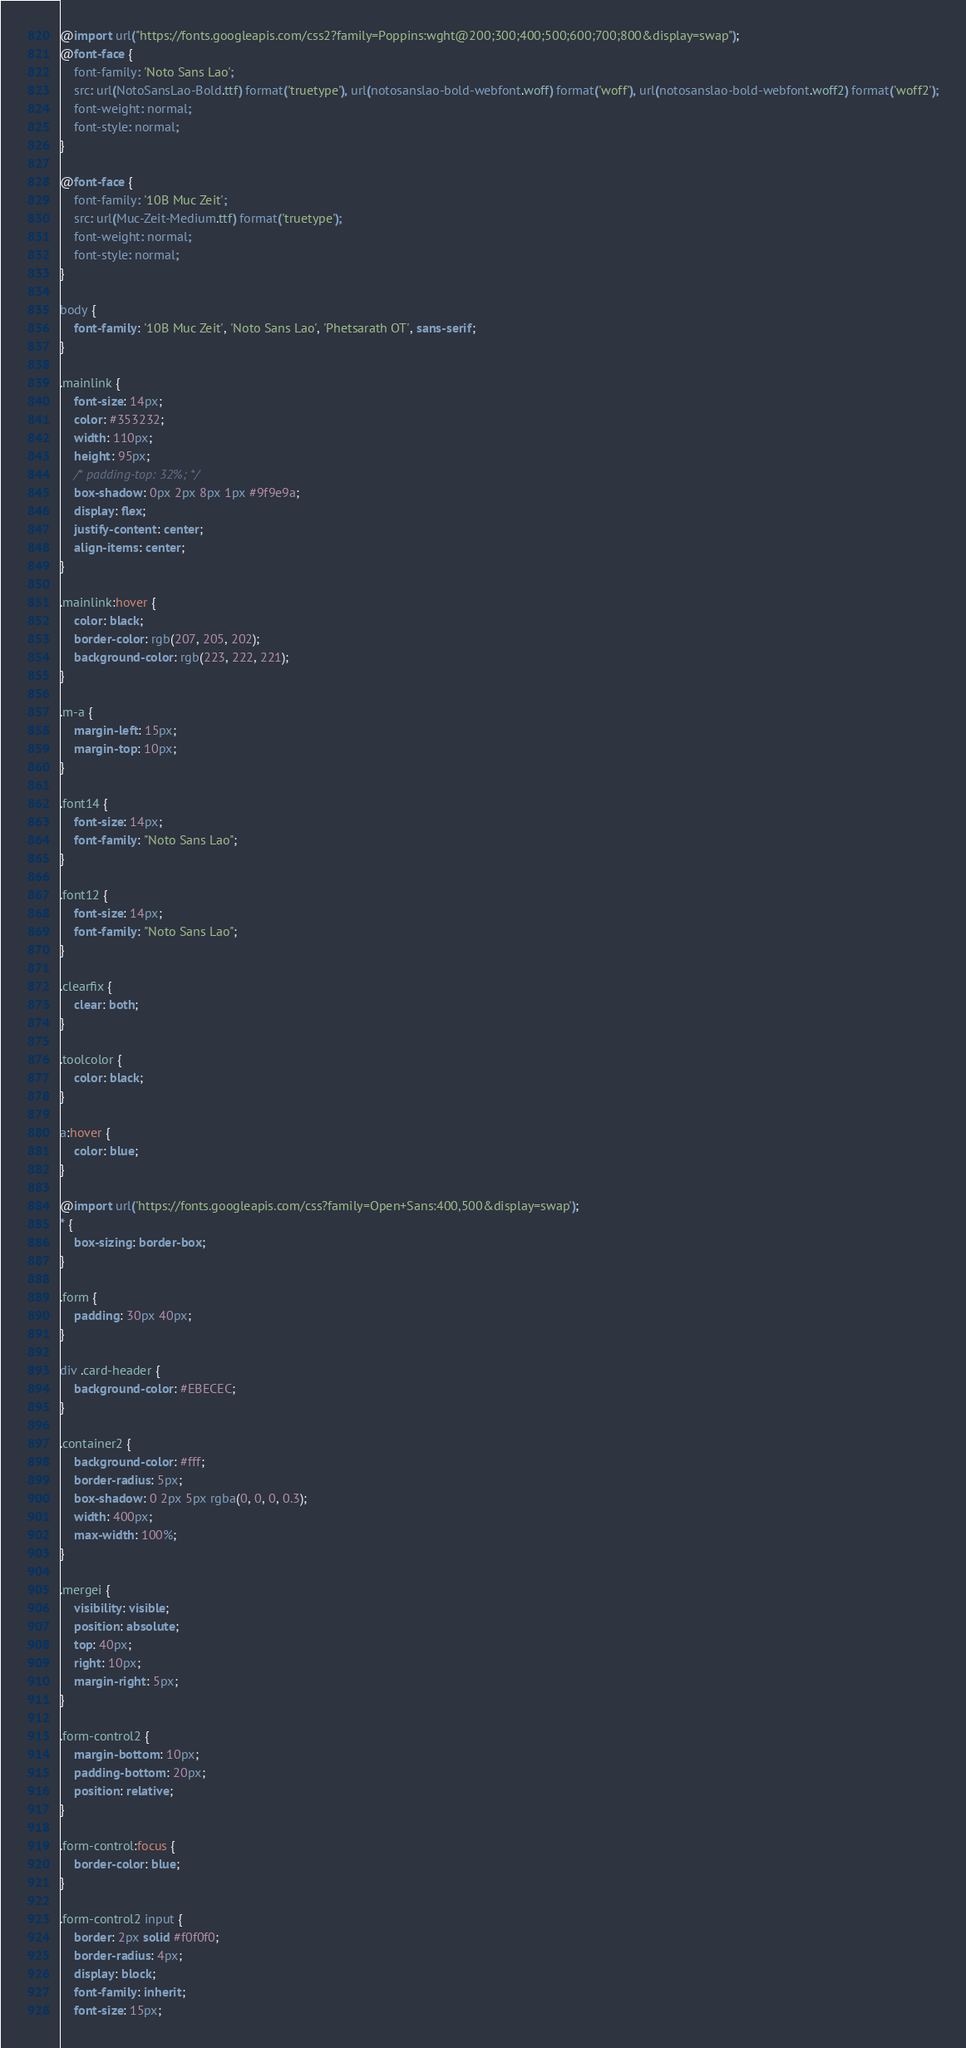<code> <loc_0><loc_0><loc_500><loc_500><_CSS_>@import url("https://fonts.googleapis.com/css2?family=Poppins:wght@200;300;400;500;600;700;800&display=swap");
@font-face {
    font-family: 'Noto Sans Lao';
    src: url(NotoSansLao-Bold.ttf) format('truetype'), url(notosanslao-bold-webfont.woff) format('woff'), url(notosanslao-bold-webfont.woff2) format('woff2');
    font-weight: normal;
    font-style: normal;
}

@font-face {
    font-family: '10B Muc Zeit';
    src: url(Muc-Zeit-Medium.ttf) format('truetype');
    font-weight: normal;
    font-style: normal;
}

body {
    font-family: '10B Muc Zeit', 'Noto Sans Lao', 'Phetsarath OT', sans-serif;
}

.mainlink {
    font-size: 14px;
    color: #353232;
    width: 110px;
    height: 95px;
    /* padding-top: 32%; */
    box-shadow: 0px 2px 8px 1px #9f9e9a;
    display: flex;
    justify-content: center;
    align-items: center;
}

.mainlink:hover {
    color: black;
    border-color: rgb(207, 205, 202);
    background-color: rgb(223, 222, 221);
}

.m-a {
    margin-left: 15px;
    margin-top: 10px;
}

.font14 {
    font-size: 14px;
    font-family: "Noto Sans Lao";
}

.font12 {
    font-size: 14px;
    font-family: "Noto Sans Lao";
}

.clearfix {
    clear: both;
}

.toolcolor {
    color: black;
}

a:hover {
    color: blue;
}

@import url('https://fonts.googleapis.com/css?family=Open+Sans:400,500&display=swap');
* {
    box-sizing: border-box;
}

.form {
    padding: 30px 40px;
}

div .card-header {
    background-color: #EBECEC;
}

.container2 {
    background-color: #fff;
    border-radius: 5px;
    box-shadow: 0 2px 5px rgba(0, 0, 0, 0.3);
    width: 400px;
    max-width: 100%;
}

.mergei {
    visibility: visible;
    position: absolute;
    top: 40px;
    right: 10px;
    margin-right: 5px;
}

.form-control2 {
    margin-bottom: 10px;
    padding-bottom: 20px;
    position: relative;
}

.form-control:focus {
    border-color: blue;
}

.form-control2 input {
    border: 2px solid #f0f0f0;
    border-radius: 4px;
    display: block;
    font-family: inherit;
    font-size: 15px;</code> 